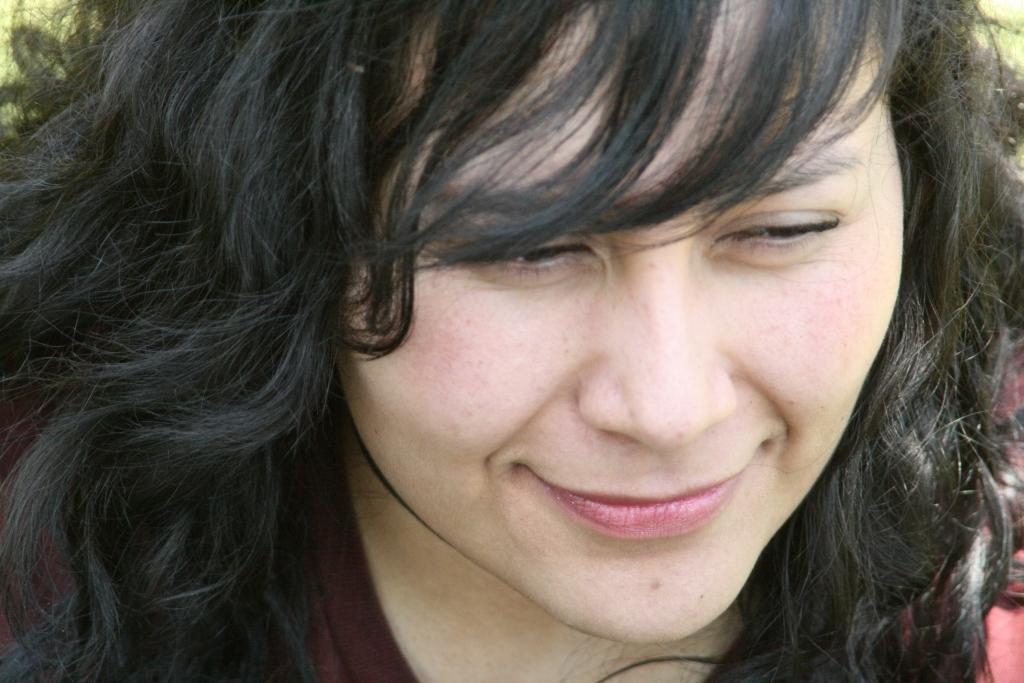What is the appearance of the person's hair in the image? The person with loose hair is visible in the image. What can be seen in the background of the image? There is greenery visible in the background of the image. What sense does the beggar appeal to in the image? There is no beggar present in the image, so it is not possible to determine which sense they might appeal to. 